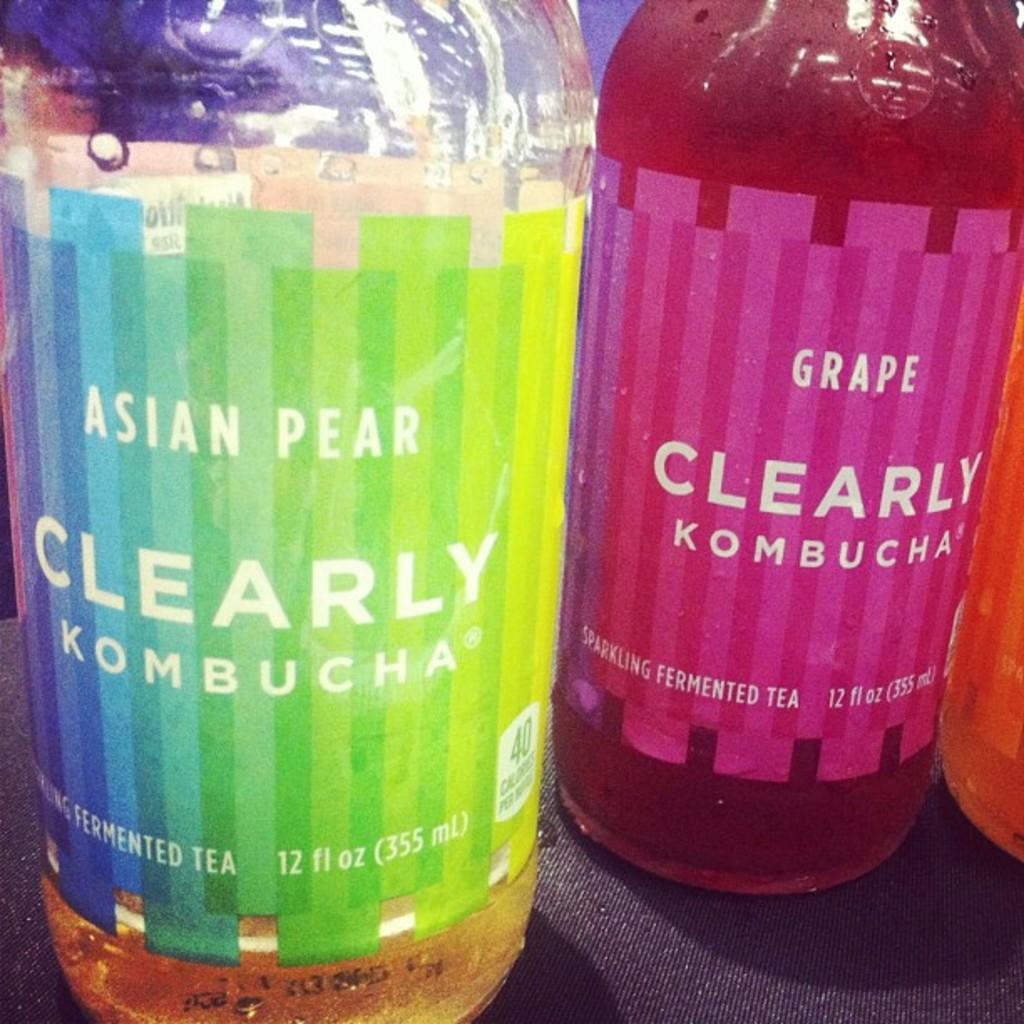What asian fermented food is shown here?
Give a very brief answer. Tea. What is the flavor on the left bottle?
Your answer should be compact. Asian pear. 